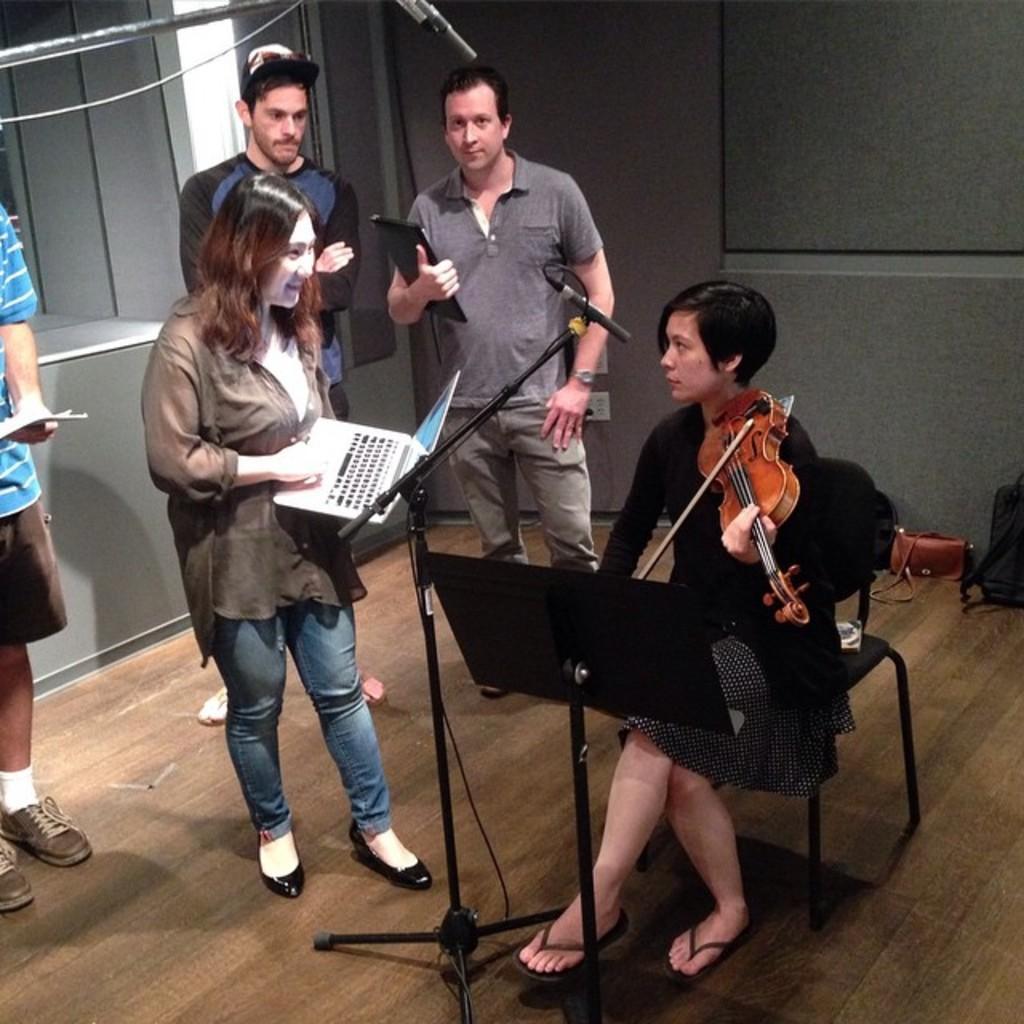Please provide a concise description of this image. In the center of the image there is a lady sitting on a chair and playing a violin and there is a stand placed before her. There is a mic as well. On the left side of the image there are people standing. The woman who is standing next to the mic is holding a laptop. 